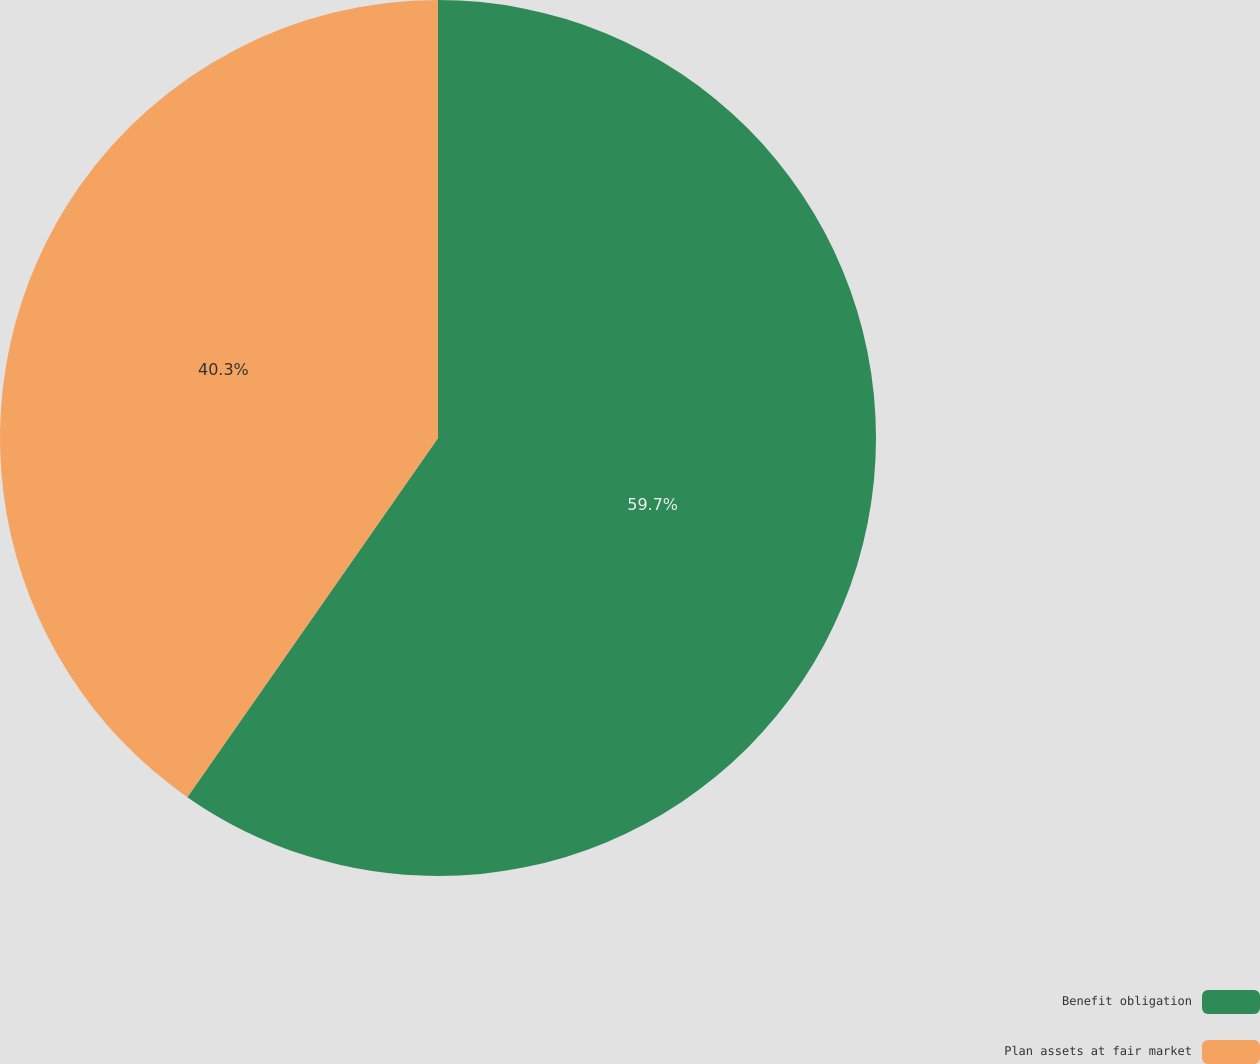<chart> <loc_0><loc_0><loc_500><loc_500><pie_chart><fcel>Benefit obligation<fcel>Plan assets at fair market<nl><fcel>59.7%<fcel>40.3%<nl></chart> 